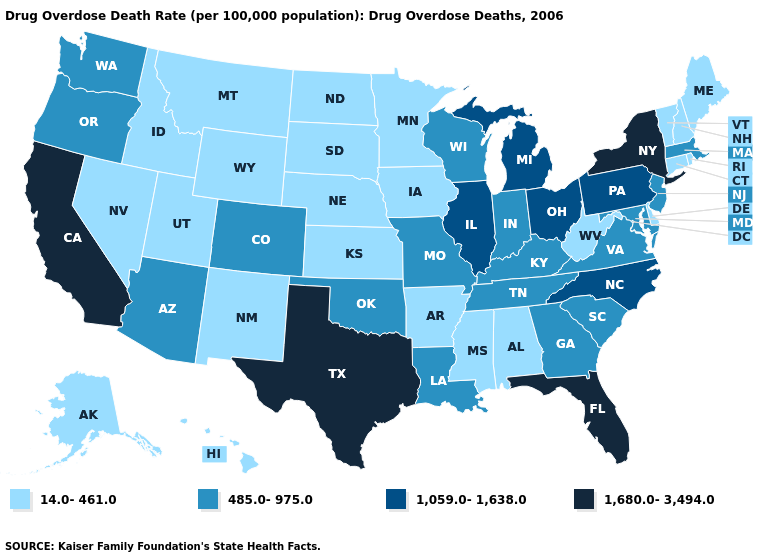Does Arkansas have the lowest value in the South?
Give a very brief answer. Yes. What is the lowest value in the USA?
Be succinct. 14.0-461.0. Name the states that have a value in the range 485.0-975.0?
Short answer required. Arizona, Colorado, Georgia, Indiana, Kentucky, Louisiana, Maryland, Massachusetts, Missouri, New Jersey, Oklahoma, Oregon, South Carolina, Tennessee, Virginia, Washington, Wisconsin. What is the value of Wisconsin?
Give a very brief answer. 485.0-975.0. Does California have the highest value in the West?
Concise answer only. Yes. Does Delaware have the lowest value in the South?
Be succinct. Yes. Does Alabama have a higher value than Wisconsin?
Be succinct. No. Does South Dakota have the lowest value in the MidWest?
Concise answer only. Yes. What is the value of South Carolina?
Answer briefly. 485.0-975.0. What is the highest value in states that border Florida?
Short answer required. 485.0-975.0. Among the states that border Virginia , does North Carolina have the highest value?
Keep it brief. Yes. What is the value of Wisconsin?
Give a very brief answer. 485.0-975.0. Does Alabama have a lower value than South Carolina?
Answer briefly. Yes. Name the states that have a value in the range 14.0-461.0?
Keep it brief. Alabama, Alaska, Arkansas, Connecticut, Delaware, Hawaii, Idaho, Iowa, Kansas, Maine, Minnesota, Mississippi, Montana, Nebraska, Nevada, New Hampshire, New Mexico, North Dakota, Rhode Island, South Dakota, Utah, Vermont, West Virginia, Wyoming. Which states hav the highest value in the Northeast?
Write a very short answer. New York. 